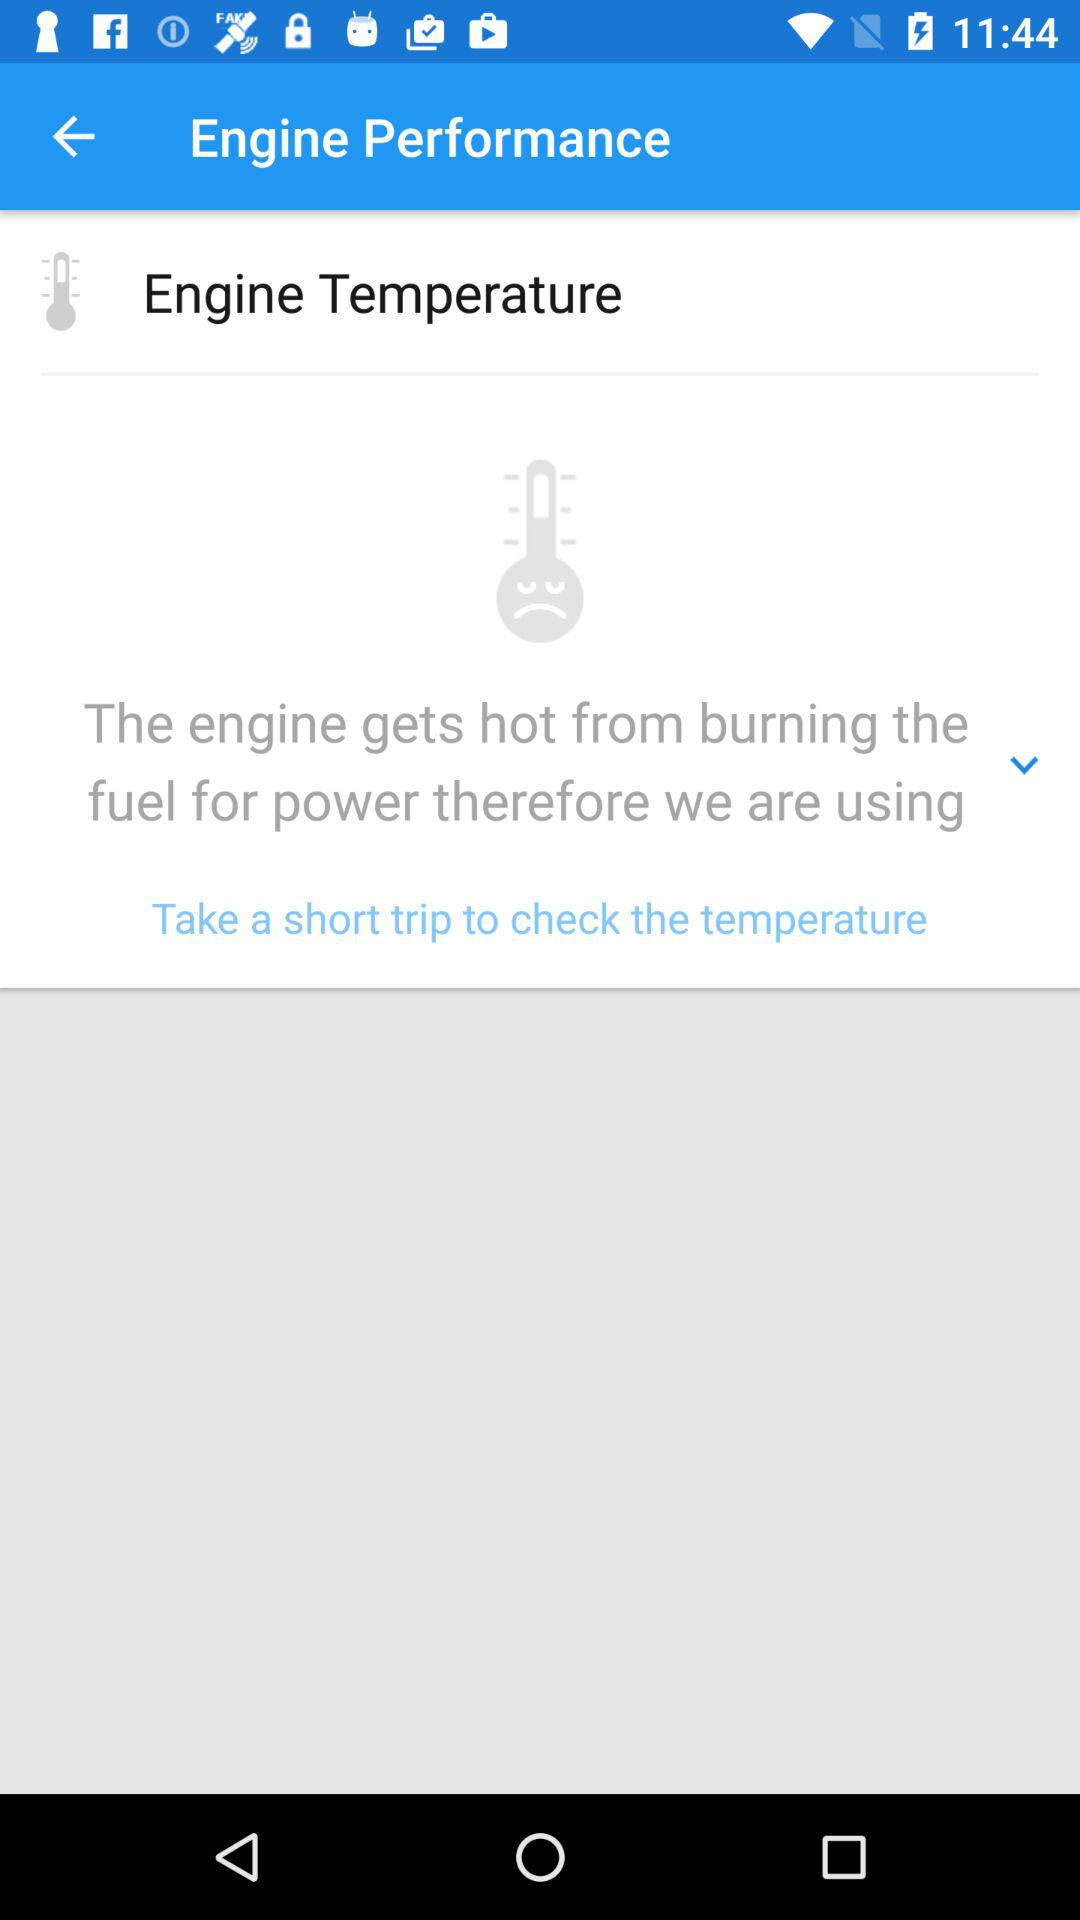How does the engine get hot? The engine gets hot by burning the fuel for power. 